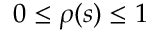<formula> <loc_0><loc_0><loc_500><loc_500>0 \leq \rho ( s ) \leq 1</formula> 